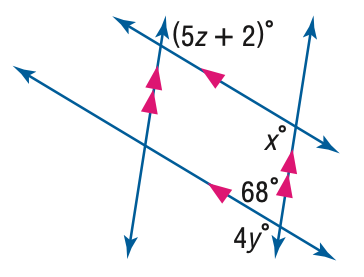Question: Find y in the figure.
Choices:
A. 22
B. 24
C. 26
D. 28
Answer with the letter. Answer: D Question: Find z in the figure.
Choices:
A. 22
B. 24
C. 26
D. 28
Answer with the letter. Answer: A Question: Find x in the figure.
Choices:
A. 68
B. 102
C. 112
D. 122
Answer with the letter. Answer: C 